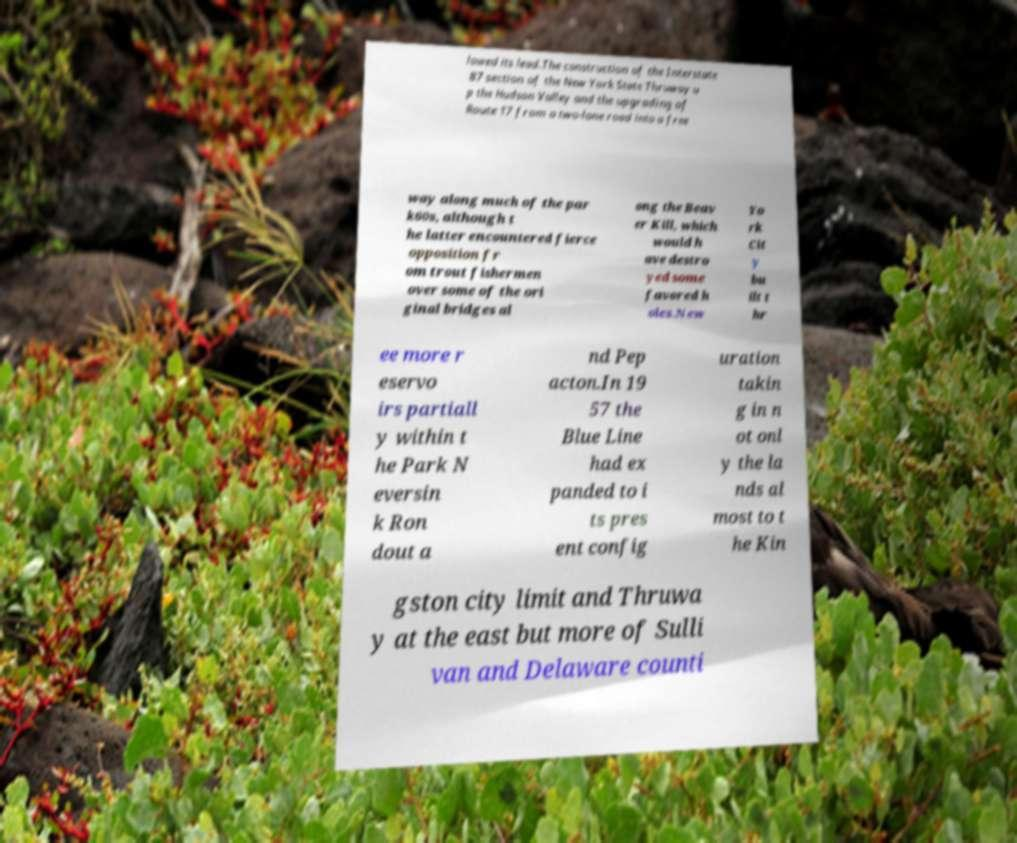I need the written content from this picture converted into text. Can you do that? lowed its lead.The construction of the Interstate 87 section of the New York State Thruway u p the Hudson Valley and the upgrading of Route 17 from a two-lane road into a free way along much of the par k60s, although t he latter encountered fierce opposition fr om trout fishermen over some of the ori ginal bridges al ong the Beav er Kill, which would h ave destro yed some favored h oles.New Yo rk Cit y bu ilt t hr ee more r eservo irs partiall y within t he Park N eversin k Ron dout a nd Pep acton.In 19 57 the Blue Line had ex panded to i ts pres ent config uration takin g in n ot onl y the la nds al most to t he Kin gston city limit and Thruwa y at the east but more of Sulli van and Delaware counti 